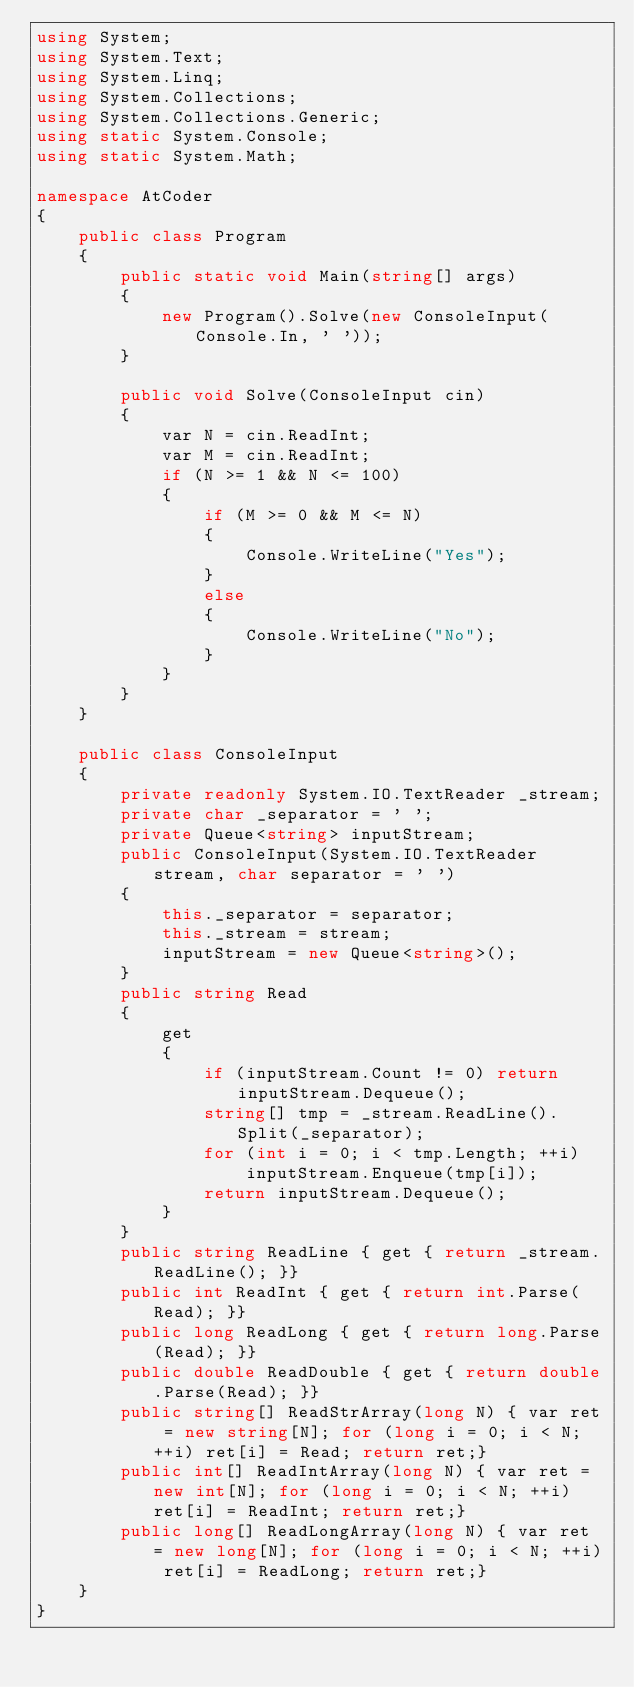<code> <loc_0><loc_0><loc_500><loc_500><_C#_>using System;
using System.Text;
using System.Linq;
using System.Collections;
using System.Collections.Generic;
using static System.Console;
using static System.Math;

namespace AtCoder
{
    public class Program
    {
        public static void Main(string[] args)
        {
            new Program().Solve(new ConsoleInput(Console.In, ' '));
        }

        public void Solve(ConsoleInput cin)
        {
            var N = cin.ReadInt;
            var M = cin.ReadInt;
            if (N >= 1 && N <= 100)
            {
                if (M >= 0 && M <= N)
                {
                    Console.WriteLine("Yes");
                }
                else
                {
                    Console.WriteLine("No");
                }
            }
        }
    }

    public class ConsoleInput
    {
        private readonly System.IO.TextReader _stream;
        private char _separator = ' ';
        private Queue<string> inputStream;
        public ConsoleInput(System.IO.TextReader stream, char separator = ' ')
        {
            this._separator = separator;
            this._stream = stream;
            inputStream = new Queue<string>();
        }
        public string Read
        {
            get
            {
                if (inputStream.Count != 0) return inputStream.Dequeue();
                string[] tmp = _stream.ReadLine().Split(_separator);
                for (int i = 0; i < tmp.Length; ++i)
                    inputStream.Enqueue(tmp[i]);
                return inputStream.Dequeue();
            }
        }
        public string ReadLine { get { return _stream.ReadLine(); }}
        public int ReadInt { get { return int.Parse(Read); }}
        public long ReadLong { get { return long.Parse(Read); }}
        public double ReadDouble { get { return double.Parse(Read); }}
        public string[] ReadStrArray(long N) { var ret = new string[N]; for (long i = 0; i < N; ++i) ret[i] = Read; return ret;}
        public int[] ReadIntArray(long N) { var ret = new int[N]; for (long i = 0; i < N; ++i) ret[i] = ReadInt; return ret;}
        public long[] ReadLongArray(long N) { var ret = new long[N]; for (long i = 0; i < N; ++i) ret[i] = ReadLong; return ret;}
    }
}</code> 